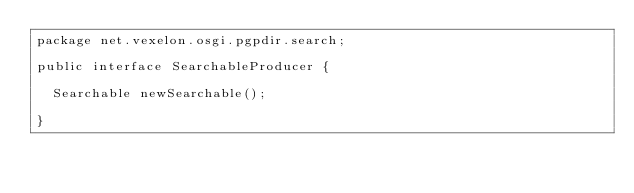Convert code to text. <code><loc_0><loc_0><loc_500><loc_500><_Java_>package net.vexelon.osgi.pgpdir.search;

public interface SearchableProducer {
	
	Searchable newSearchable();

}
</code> 